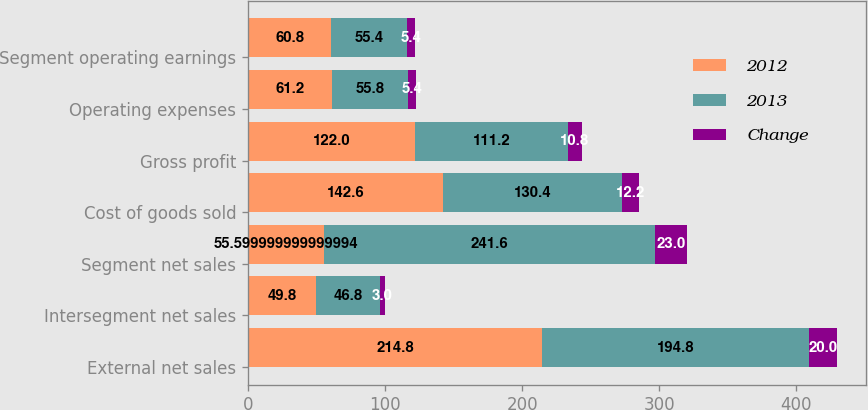<chart> <loc_0><loc_0><loc_500><loc_500><stacked_bar_chart><ecel><fcel>External net sales<fcel>Intersegment net sales<fcel>Segment net sales<fcel>Cost of goods sold<fcel>Gross profit<fcel>Operating expenses<fcel>Segment operating earnings<nl><fcel>2012<fcel>214.8<fcel>49.8<fcel>55.6<fcel>142.6<fcel>122<fcel>61.2<fcel>60.8<nl><fcel>2013<fcel>194.8<fcel>46.8<fcel>241.6<fcel>130.4<fcel>111.2<fcel>55.8<fcel>55.4<nl><fcel>Change<fcel>20<fcel>3<fcel>23<fcel>12.2<fcel>10.8<fcel>5.4<fcel>5.4<nl></chart> 